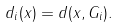<formula> <loc_0><loc_0><loc_500><loc_500>d _ { i } ( x ) = d ( x , G _ { i } ) .</formula> 